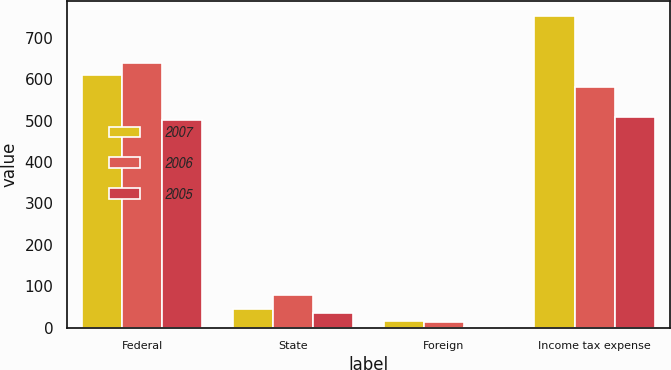Convert chart. <chart><loc_0><loc_0><loc_500><loc_500><stacked_bar_chart><ecel><fcel>Federal<fcel>State<fcel>Foreign<fcel>Income tax expense<nl><fcel>2007<fcel>609<fcel>45<fcel>16<fcel>752<nl><fcel>2006<fcel>640<fcel>78<fcel>14<fcel>581<nl><fcel>2005<fcel>502<fcel>36<fcel>1<fcel>509<nl></chart> 